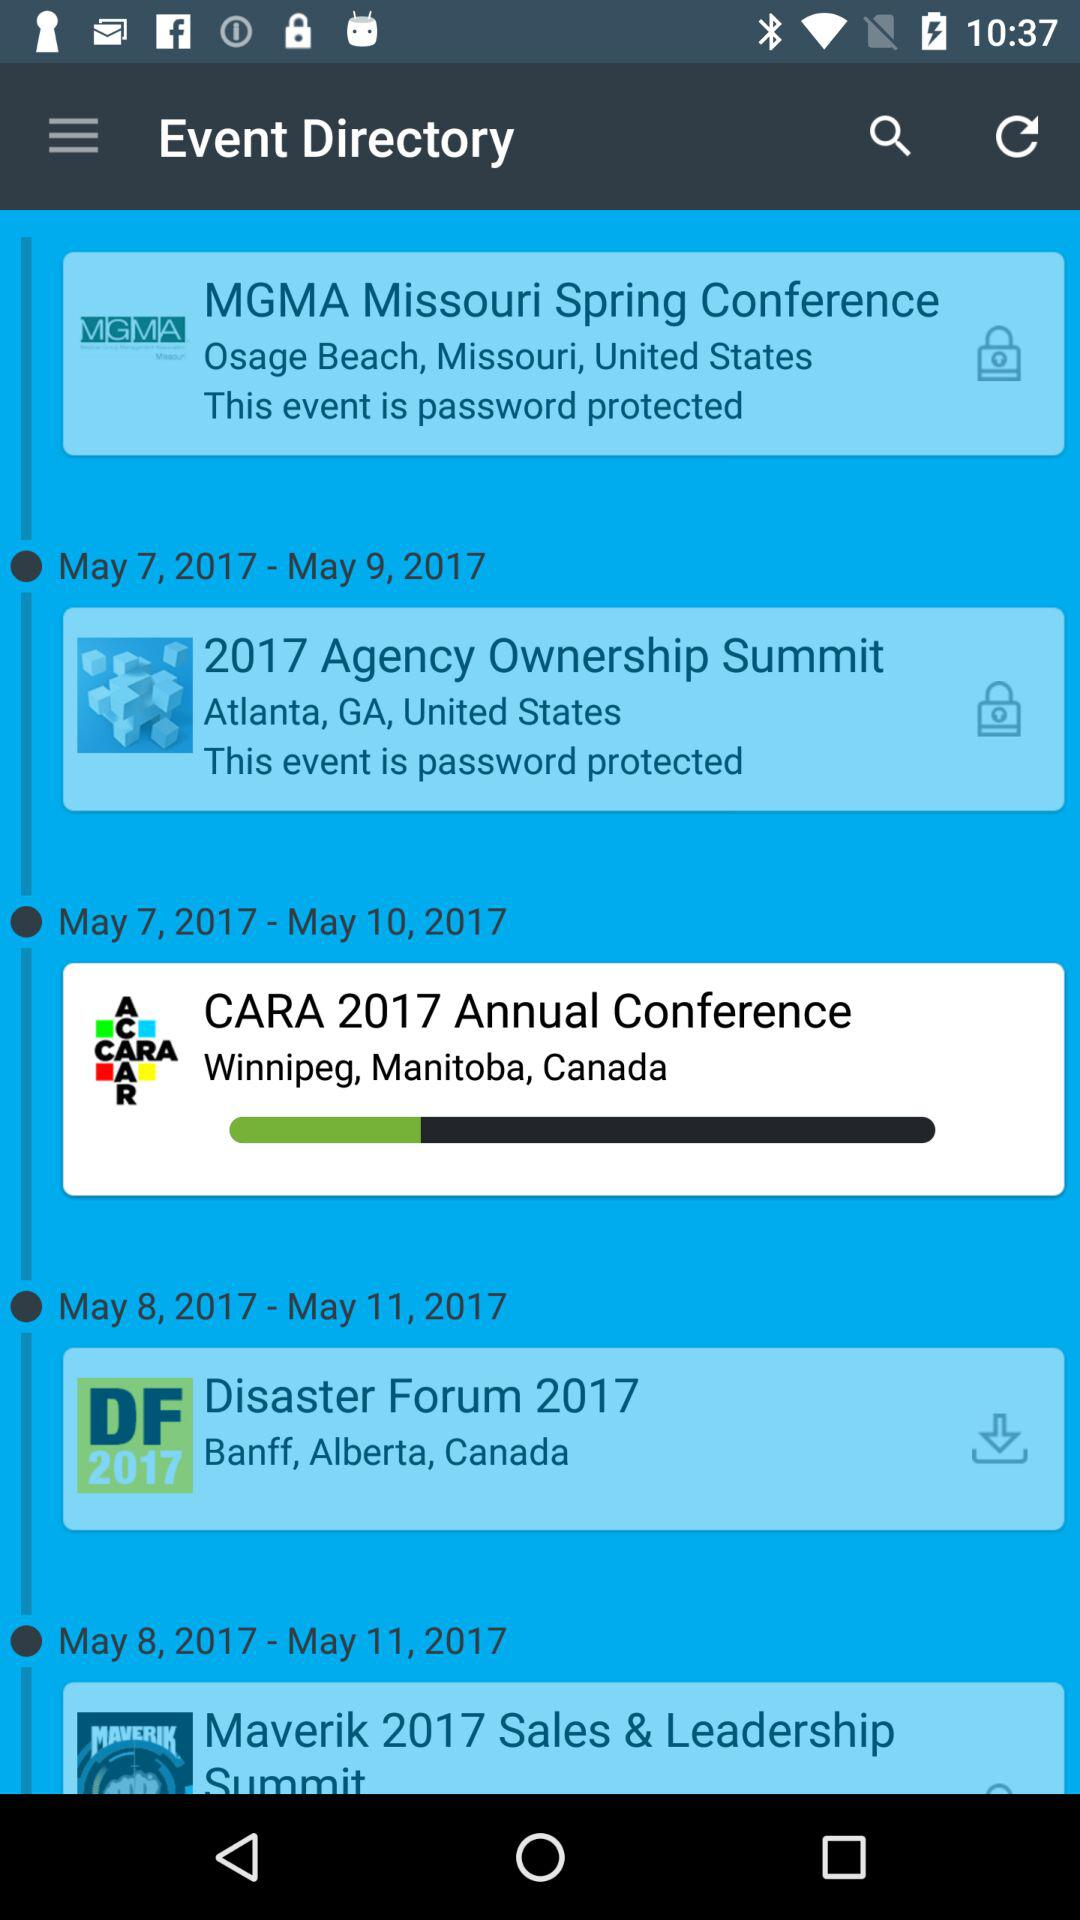What is the location of the "CARA 2017 Annual Conference"? The location is Winnipeg, Manitoba, Canada. 